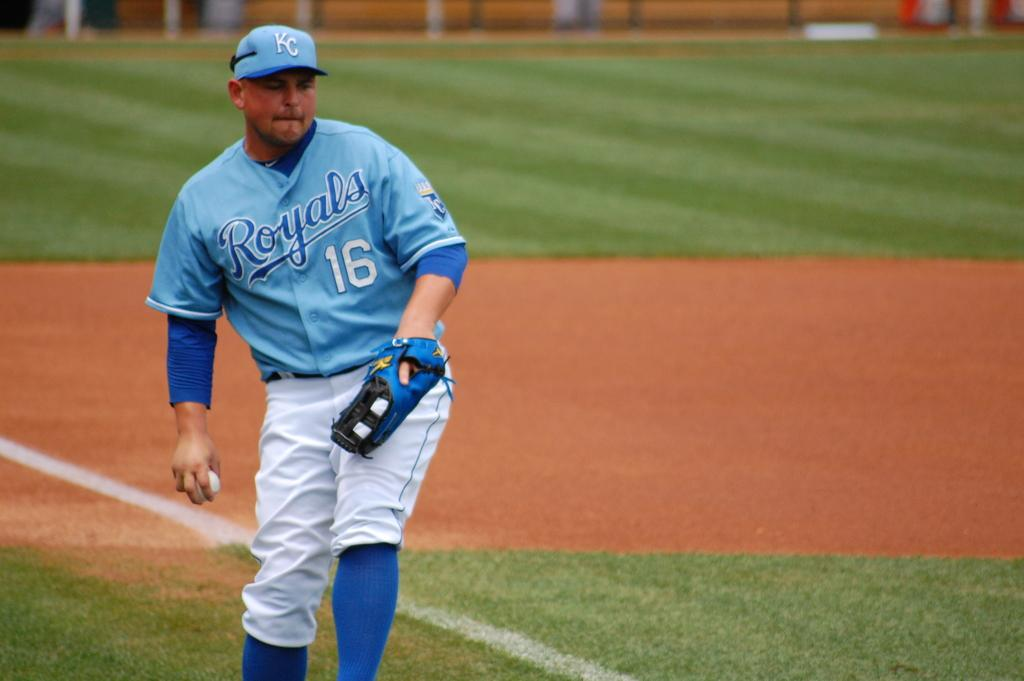Provide a one-sentence caption for the provided image. Number sixteen for the Royals prepares to throw a baseball. 